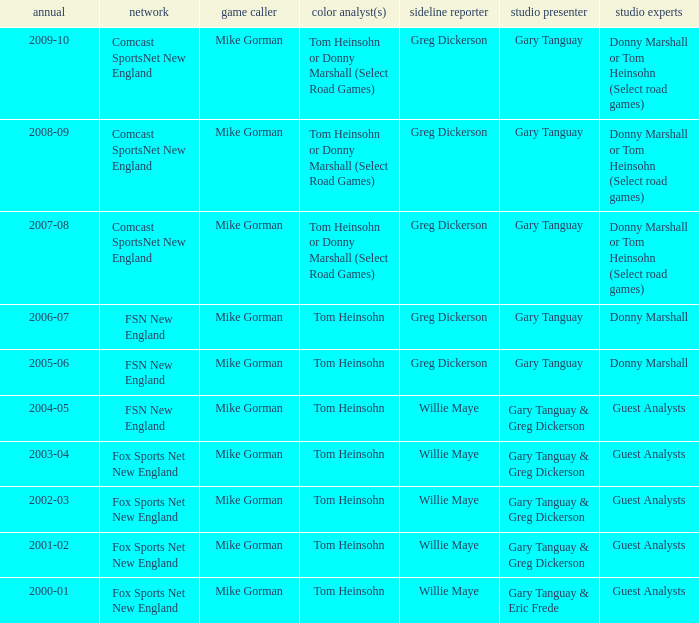WHich Color commentatorhas a Studio host of gary tanguay & eric frede? Tom Heinsohn. 